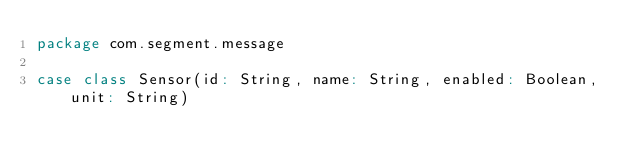Convert code to text. <code><loc_0><loc_0><loc_500><loc_500><_Scala_>package com.segment.message

case class Sensor(id: String, name: String, enabled: Boolean, unit: String)
</code> 